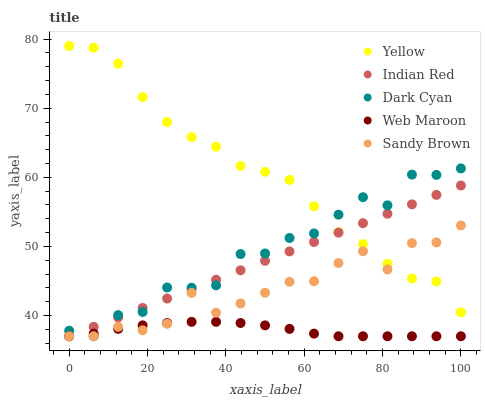Does Web Maroon have the minimum area under the curve?
Answer yes or no. Yes. Does Yellow have the maximum area under the curve?
Answer yes or no. Yes. Does Sandy Brown have the minimum area under the curve?
Answer yes or no. No. Does Sandy Brown have the maximum area under the curve?
Answer yes or no. No. Is Indian Red the smoothest?
Answer yes or no. Yes. Is Dark Cyan the roughest?
Answer yes or no. Yes. Is Sandy Brown the smoothest?
Answer yes or no. No. Is Sandy Brown the roughest?
Answer yes or no. No. Does Dark Cyan have the lowest value?
Answer yes or no. Yes. Does Yellow have the lowest value?
Answer yes or no. No. Does Yellow have the highest value?
Answer yes or no. Yes. Does Sandy Brown have the highest value?
Answer yes or no. No. Is Web Maroon less than Yellow?
Answer yes or no. Yes. Is Yellow greater than Web Maroon?
Answer yes or no. Yes. Does Sandy Brown intersect Web Maroon?
Answer yes or no. Yes. Is Sandy Brown less than Web Maroon?
Answer yes or no. No. Is Sandy Brown greater than Web Maroon?
Answer yes or no. No. Does Web Maroon intersect Yellow?
Answer yes or no. No. 